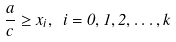<formula> <loc_0><loc_0><loc_500><loc_500>\frac { a } { c } \geq x _ { i } , \ i = 0 , 1 , 2 , \dots , k</formula> 